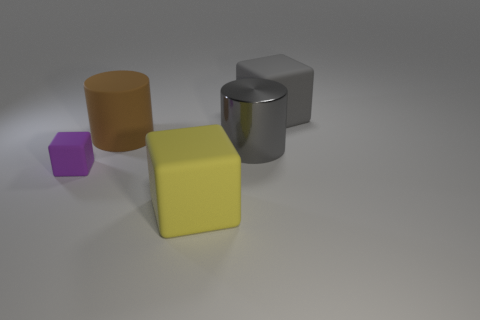Are there fewer small purple objects behind the matte cylinder than purple things?
Provide a succinct answer. Yes. There is a yellow thing on the left side of the big matte object to the right of the big object in front of the purple matte block; what is its shape?
Provide a short and direct response. Cube. Do the yellow thing and the tiny purple thing have the same shape?
Give a very brief answer. Yes. What number of other objects are the same shape as the metal object?
Offer a terse response. 1. What color is the other cylinder that is the same size as the gray shiny cylinder?
Offer a terse response. Brown. Are there an equal number of tiny rubber things right of the big yellow cube and gray objects?
Make the answer very short. No. What shape is the matte object that is behind the yellow matte cube and to the right of the brown matte cylinder?
Provide a short and direct response. Cube. Does the gray cylinder have the same size as the brown rubber cylinder?
Ensure brevity in your answer.  Yes. Is there a large cube made of the same material as the brown cylinder?
Keep it short and to the point. Yes. The matte object that is the same color as the large shiny cylinder is what size?
Provide a succinct answer. Large. 